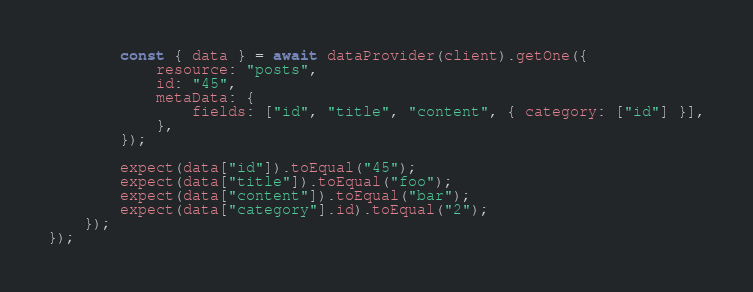<code> <loc_0><loc_0><loc_500><loc_500><_TypeScript_>        const { data } = await dataProvider(client).getOne({
            resource: "posts",
            id: "45",
            metaData: {
                fields: ["id", "title", "content", { category: ["id"] }],
            },
        });

        expect(data["id"]).toEqual("45");
        expect(data["title"]).toEqual("foo");
        expect(data["content"]).toEqual("bar");
        expect(data["category"].id).toEqual("2");
    });
});
</code> 